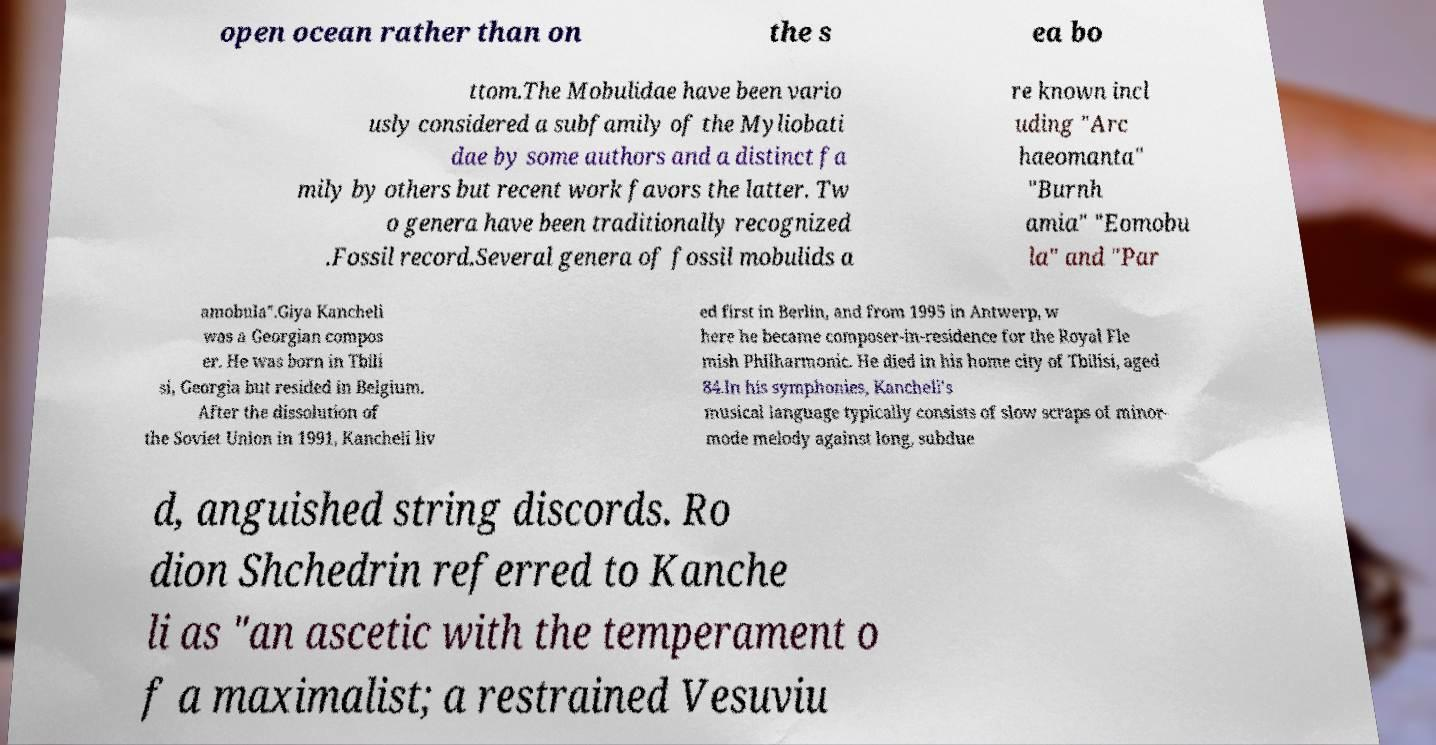Could you extract and type out the text from this image? open ocean rather than on the s ea bo ttom.The Mobulidae have been vario usly considered a subfamily of the Myliobati dae by some authors and a distinct fa mily by others but recent work favors the latter. Tw o genera have been traditionally recognized .Fossil record.Several genera of fossil mobulids a re known incl uding "Arc haeomanta" "Burnh amia" "Eomobu la" and "Par amobula".Giya Kancheli was a Georgian compos er. He was born in Tbili si, Georgia but resided in Belgium. After the dissolution of the Soviet Union in 1991, Kancheli liv ed first in Berlin, and from 1995 in Antwerp, w here he became composer-in-residence for the Royal Fle mish Philharmonic. He died in his home city of Tbilisi, aged 84.In his symphonies, Kancheli's musical language typically consists of slow scraps of minor- mode melody against long, subdue d, anguished string discords. Ro dion Shchedrin referred to Kanche li as "an ascetic with the temperament o f a maximalist; a restrained Vesuviu 